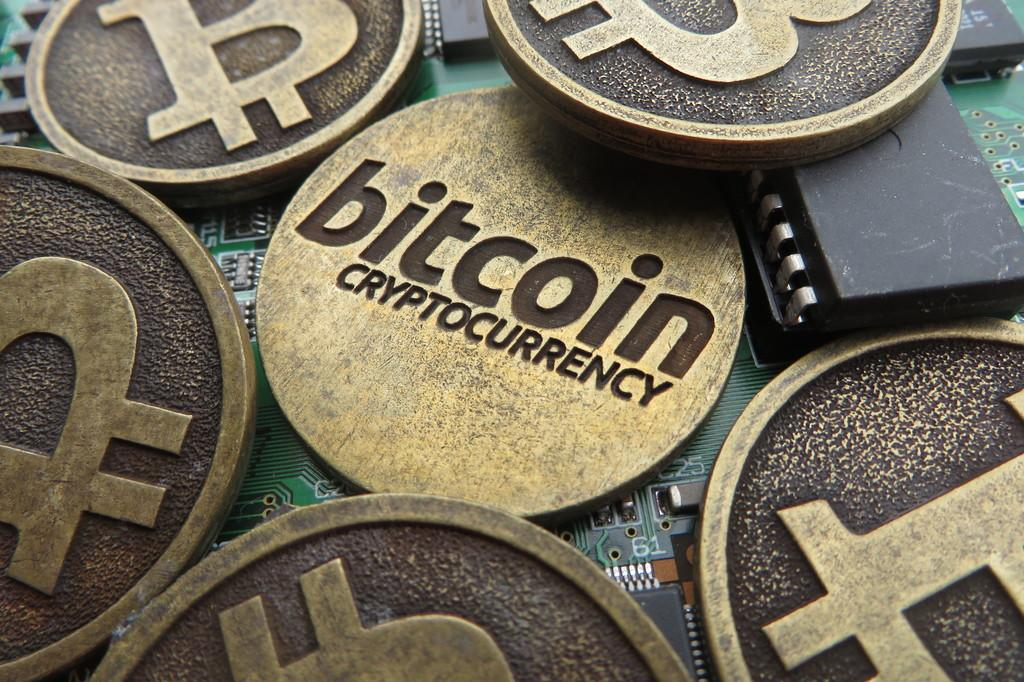<image>
Render a clear and concise summary of the photo. bronze and gold coins next to each other with one of them labeled as 'bitcoin cryptocurrency' 